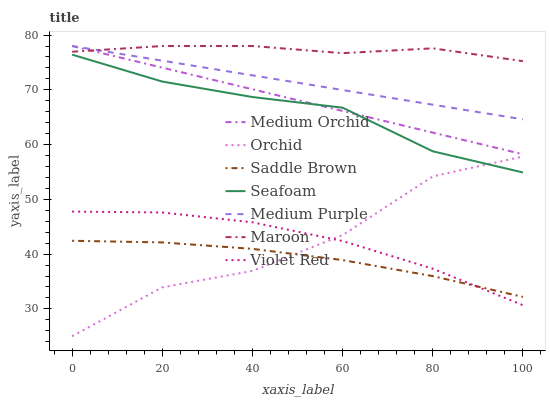Does Saddle Brown have the minimum area under the curve?
Answer yes or no. Yes. Does Maroon have the maximum area under the curve?
Answer yes or no. Yes. Does Medium Orchid have the minimum area under the curve?
Answer yes or no. No. Does Medium Orchid have the maximum area under the curve?
Answer yes or no. No. Is Medium Orchid the smoothest?
Answer yes or no. Yes. Is Orchid the roughest?
Answer yes or no. Yes. Is Seafoam the smoothest?
Answer yes or no. No. Is Seafoam the roughest?
Answer yes or no. No. Does Medium Orchid have the lowest value?
Answer yes or no. No. Does Medium Purple have the highest value?
Answer yes or no. Yes. Does Seafoam have the highest value?
Answer yes or no. No. Is Violet Red less than Medium Orchid?
Answer yes or no. Yes. Is Medium Purple greater than Saddle Brown?
Answer yes or no. Yes. Does Seafoam intersect Orchid?
Answer yes or no. Yes. Is Seafoam less than Orchid?
Answer yes or no. No. Is Seafoam greater than Orchid?
Answer yes or no. No. Does Violet Red intersect Medium Orchid?
Answer yes or no. No. 